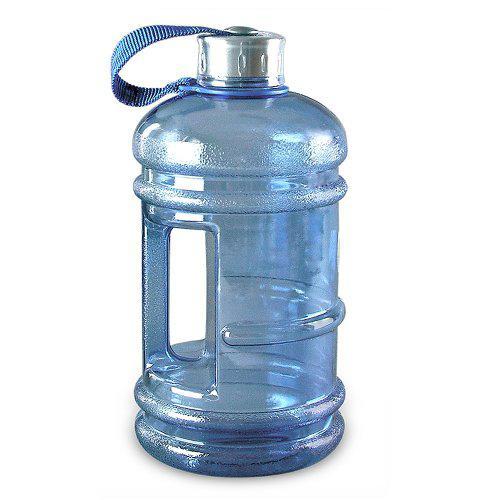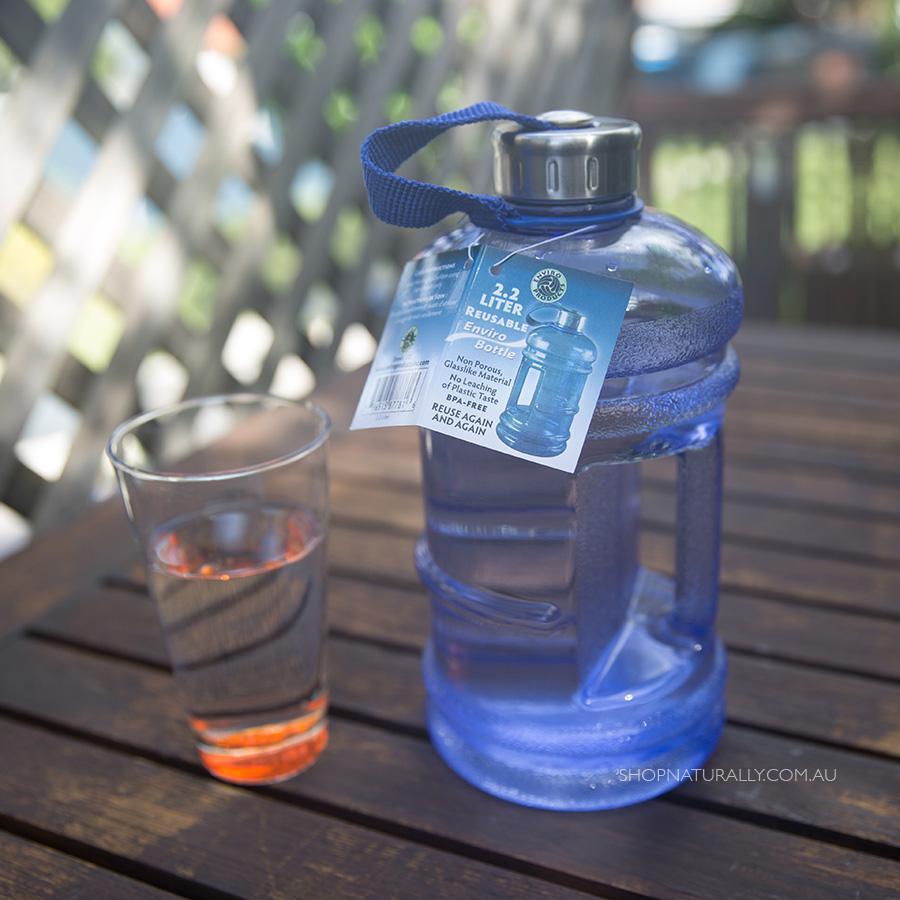The first image is the image on the left, the second image is the image on the right. Considering the images on both sides, is "At least one image shows a stout jug with a loop-type handle." valid? Answer yes or no. Yes. The first image is the image on the left, the second image is the image on the right. Evaluate the accuracy of this statement regarding the images: "There is at least three containers with lids on them.". Is it true? Answer yes or no. No. 